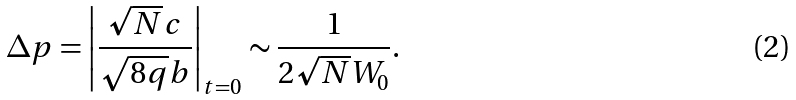<formula> <loc_0><loc_0><loc_500><loc_500>\Delta p & = \left | \frac { \sqrt { N } c } { \sqrt { 8 q } b } \right | _ { t = 0 } \sim \frac { 1 } { 2 \sqrt { N } W _ { 0 } } .</formula> 